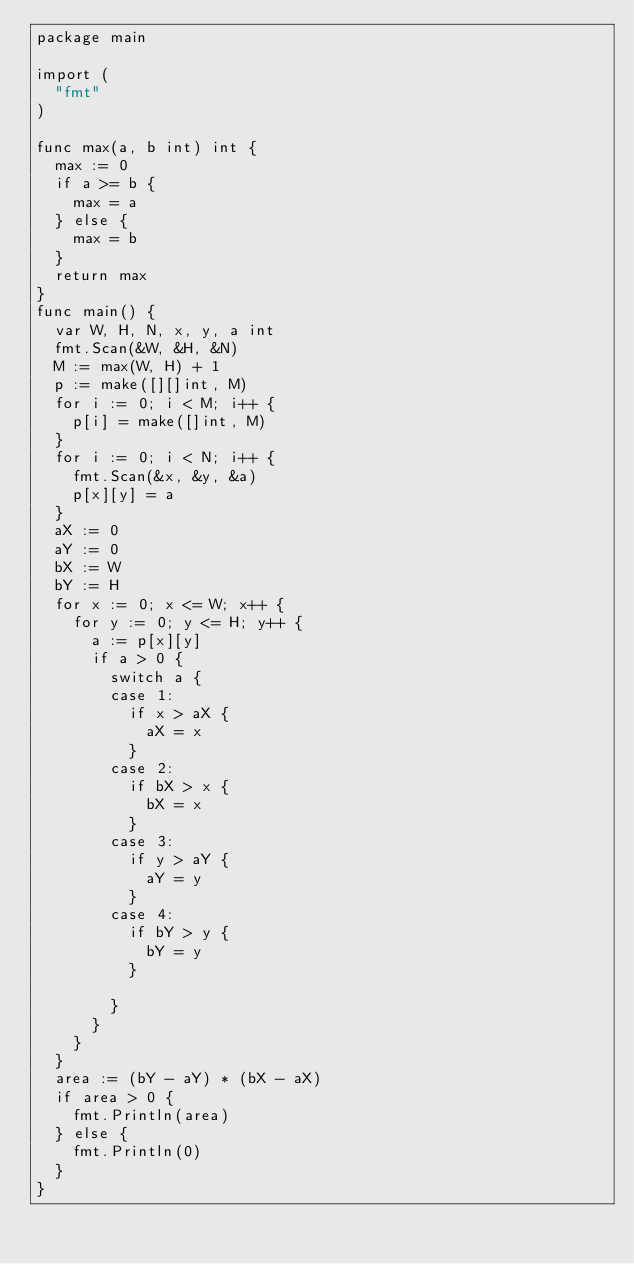<code> <loc_0><loc_0><loc_500><loc_500><_Go_>package main

import (
	"fmt"
)

func max(a, b int) int {
	max := 0
	if a >= b {
		max = a
	} else {
		max = b
	}
	return max
}
func main() {
	var W, H, N, x, y, a int
	fmt.Scan(&W, &H, &N)
	M := max(W, H) + 1
	p := make([][]int, M)
	for i := 0; i < M; i++ {
		p[i] = make([]int, M)
	}
	for i := 0; i < N; i++ {
		fmt.Scan(&x, &y, &a)
		p[x][y] = a
	}
	aX := 0
	aY := 0
	bX := W
	bY := H
	for x := 0; x <= W; x++ {
		for y := 0; y <= H; y++ {
			a := p[x][y]
			if a > 0 {
				switch a {
				case 1:
					if x > aX {
						aX = x
					}
				case 2:
					if bX > x {
						bX = x
					}
				case 3:
					if y > aY {
						aY = y
					}
				case 4:
					if bY > y {
						bY = y
					}

				}
			}
		}
	}
	area := (bY - aY) * (bX - aX)
	if area > 0 {
		fmt.Println(area)
	} else {
		fmt.Println(0)
	}
}
</code> 